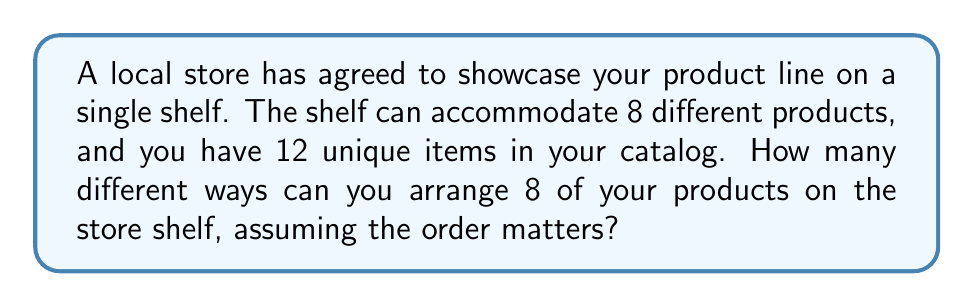Can you solve this math problem? Let's approach this step-by-step:

1) This is a permutation problem. We are selecting 8 products out of 12 and arranging them in a specific order.

2) The formula for permutations is:

   $$P(n,r) = \frac{n!}{(n-r)!}$$

   Where $n$ is the total number of items to choose from, and $r$ is the number of items being arranged.

3) In this case, $n = 12$ (total products in the catalog) and $r = 8$ (products on the shelf).

4) Plugging these numbers into the formula:

   $$P(12,8) = \frac{12!}{(12-8)!} = \frac{12!}{4!}$$

5) Expand this:
   
   $$\frac{12 \times 11 \times 10 \times 9 \times 8 \times 7 \times 6 \times 5 \times 4!}{4!}$$

6) The $4!$ cancels out in the numerator and denominator:

   $$12 \times 11 \times 10 \times 9 \times 8 \times 7 \times 6 \times 5 = 19,958,400$$

Therefore, there are 19,958,400 different ways to arrange 8 products out of 12 on the store shelf.
Answer: 19,958,400 